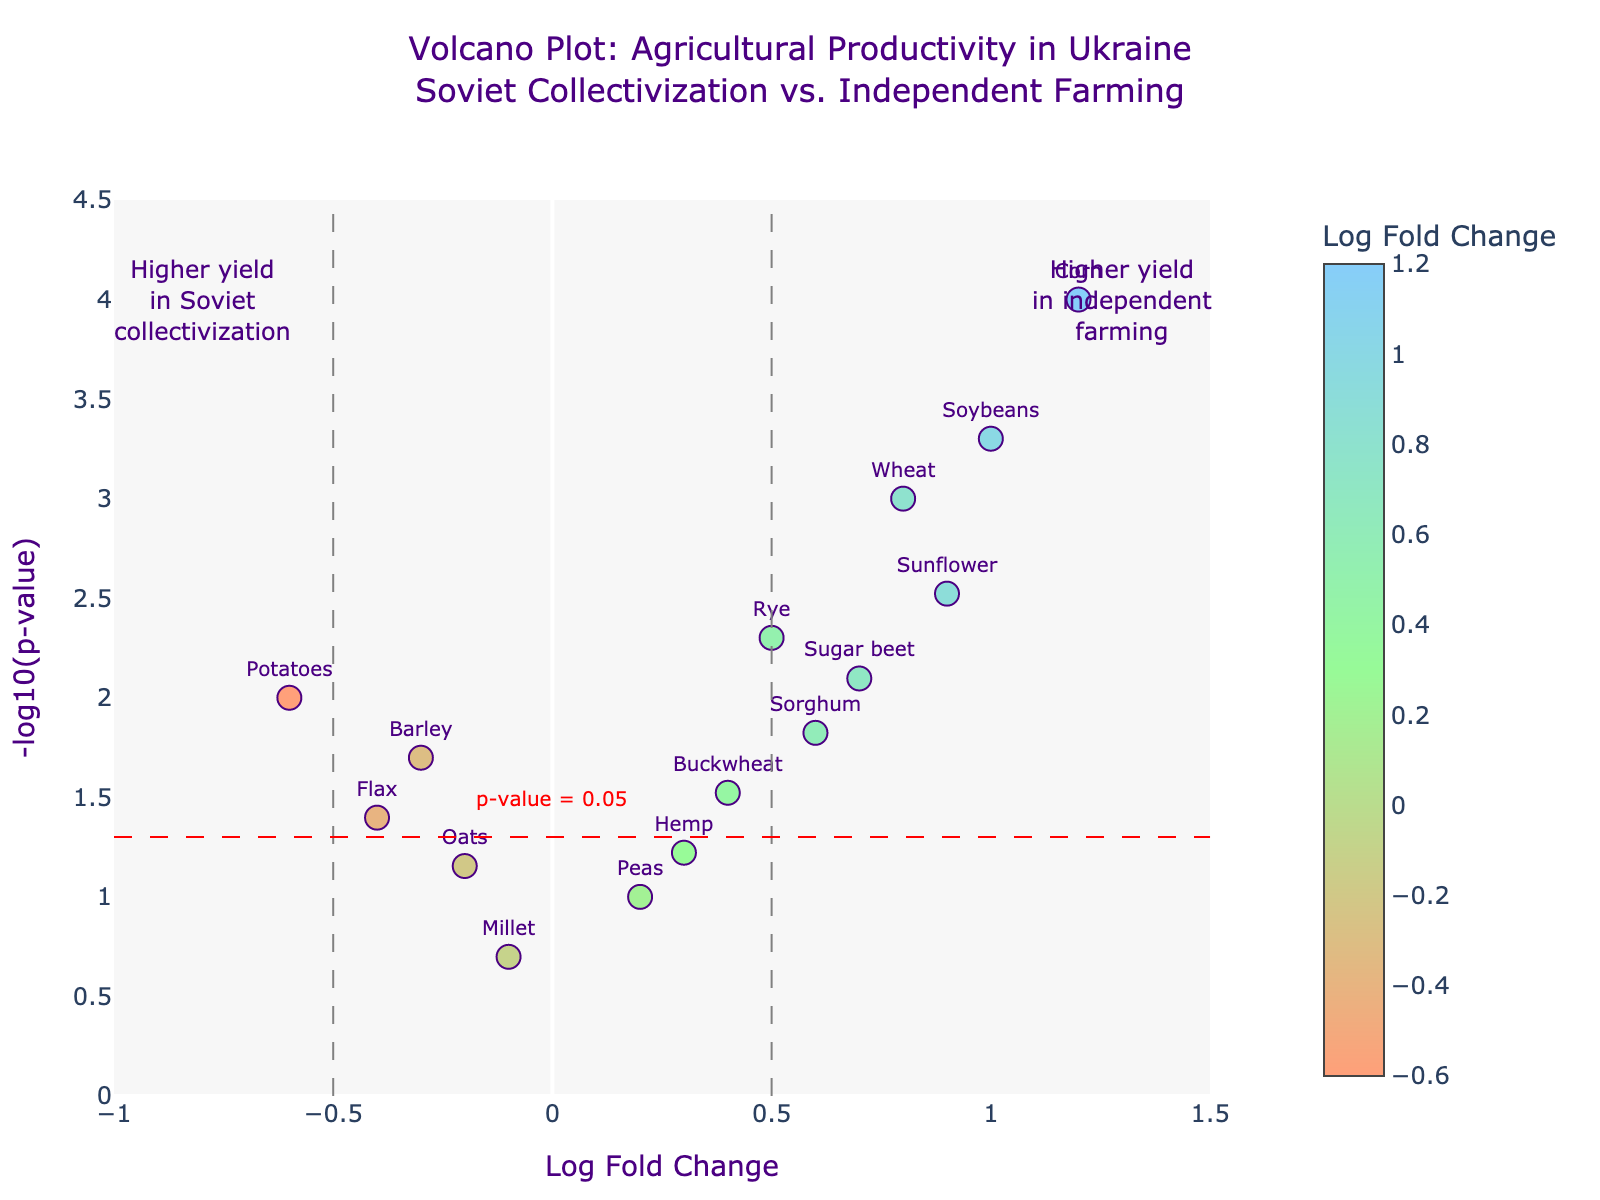How many crops have higher yields in independent farming compared to Soviet collectivization? From the plot, we observe that data points with positive Log Fold Change values indicate higher yields in independent farming. We count the number of such data points.
Answer: 10 Which crop has the most statistically significant difference in yield? The statistical significance is indicated by the -log10(p-value) on the y-axis. The highest point on the plot corresponds to the smallest p-value. From the hover information or inspecting the highest point, we identify the crop.
Answer: Corn What is the log fold change and p-value for Potatoes? We locate the data point labeled "Potatoes" and use the hover information or spatial coordinates to determine the Log Fold Change and p-value.
Answer: Log Fold Change: -0.6, p-value: 0.01 Which crop has the closest yield difference to zero but is still statistically significant? We need crops with Log Fold Change close to 0 and a significant p-value (< 0.05). We can observe or hover over these data points to find the closest to Log Fold Change of 0.
Answer: Barley How many crops show a statistically significant difference in yield? Significant p-value is less than 0.05. These can be identified by data points above the horizontal line at -log10(0.05) ≈ 1.301. We count these points.
Answer: 10 Which crop has a higher yield difference: Rye or Sunflower? We compare the Log Fold Change values for Rye (0.5) and Sunflower (0.9). The higher value indicates greater yield difference.
Answer: Sunflower Is Peas statistically significant in yield difference? We check the position of Peas relative to the horizontal significance threshold line. If it is below the line or has a p-value > 0.05, it is not significant.
Answer: No What is the color trend used for representing Log Fold Change values? The color scale transitions from one color to another to represent different magnitudes of Log Fold Change. Observing the legend or the data points, we recognize the pattern.
Answer: Gradient from red to green to blue Which area on the plot represents a higher yield in Soviet collectivization? Positive Log Fold Change values indicate higher yields in independent farming, so negative values (to the left) indicate higher yields under Soviet collectivization, as noted by the annotations.
Answer: Left side What is the p-value threshold indicated by the horizontal line? The horizontal line marks the -log10(0.05) which is the typical p-value threshold (0.05). We convert it visually from the plot.
Answer: 0.05 